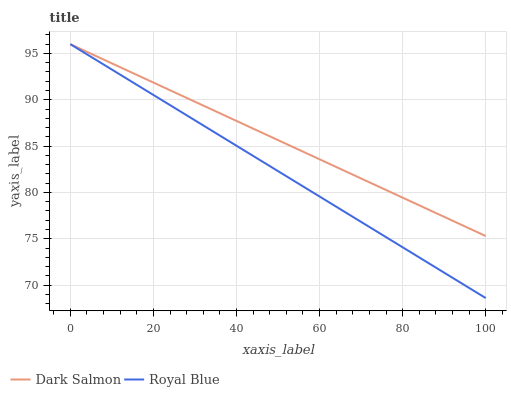Does Royal Blue have the minimum area under the curve?
Answer yes or no. Yes. Does Dark Salmon have the maximum area under the curve?
Answer yes or no. Yes. Does Dark Salmon have the minimum area under the curve?
Answer yes or no. No. Is Dark Salmon the smoothest?
Answer yes or no. Yes. Is Royal Blue the roughest?
Answer yes or no. Yes. Is Dark Salmon the roughest?
Answer yes or no. No. Does Royal Blue have the lowest value?
Answer yes or no. Yes. Does Dark Salmon have the lowest value?
Answer yes or no. No. Does Dark Salmon have the highest value?
Answer yes or no. Yes. Does Dark Salmon intersect Royal Blue?
Answer yes or no. Yes. Is Dark Salmon less than Royal Blue?
Answer yes or no. No. Is Dark Salmon greater than Royal Blue?
Answer yes or no. No. 